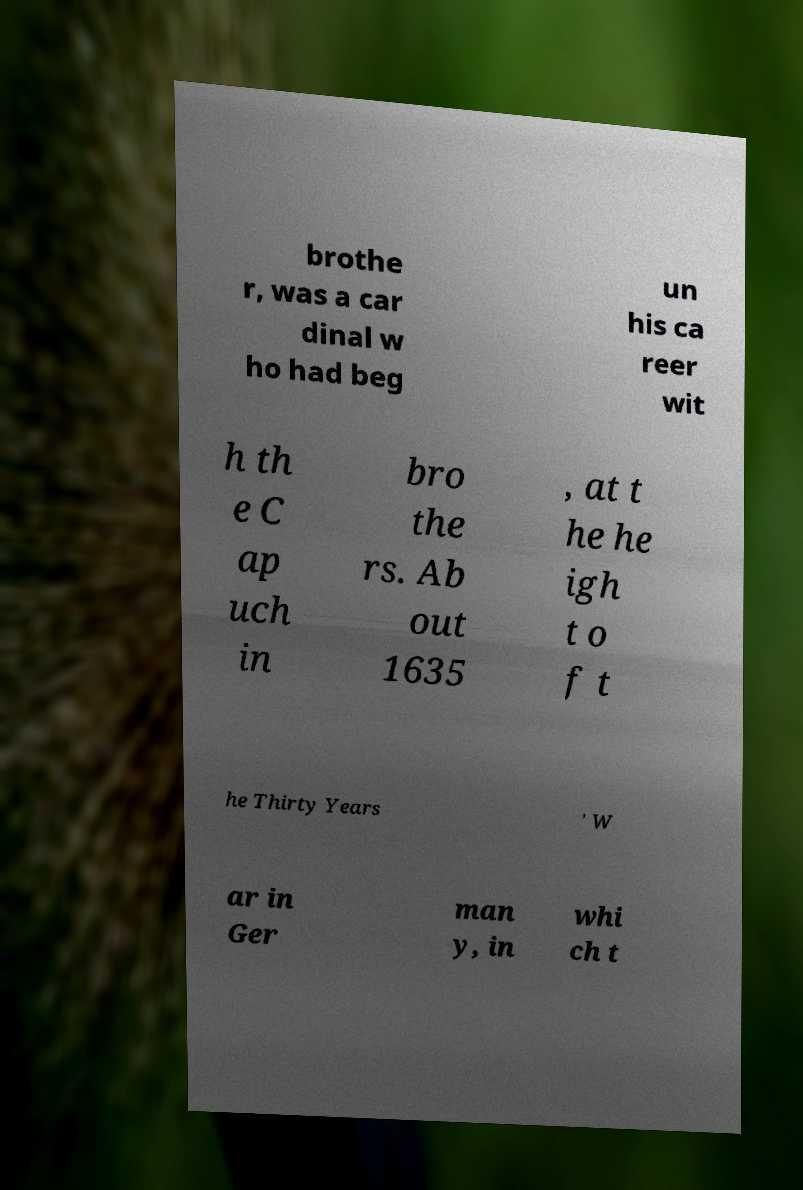I need the written content from this picture converted into text. Can you do that? brothe r, was a car dinal w ho had beg un his ca reer wit h th e C ap uch in bro the rs. Ab out 1635 , at t he he igh t o f t he Thirty Years ' W ar in Ger man y, in whi ch t 